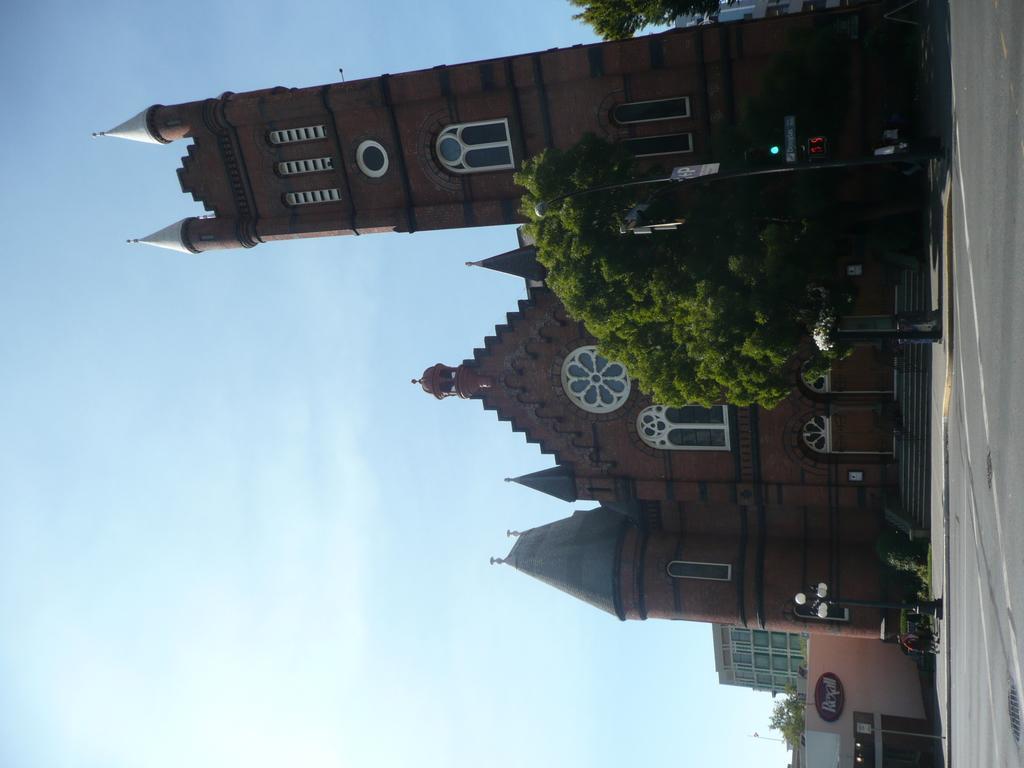Could you give a brief overview of what you see in this image? In this image, there are a few buildings, trees, poles, boards, stairs. We can see the ground with some objects. We can also see the sky. 